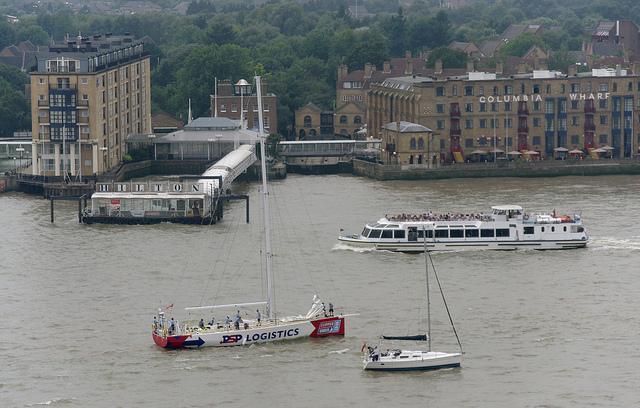How many boats are in the water?
Give a very brief answer. 3. How many boats are there?
Give a very brief answer. 3. How many boats can you see?
Give a very brief answer. 2. 